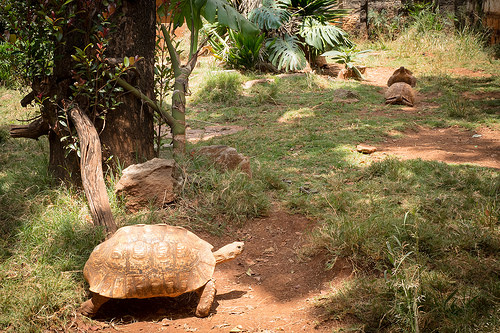<image>
Is the tortoise on the grass? No. The tortoise is not positioned on the grass. They may be near each other, but the tortoise is not supported by or resting on top of the grass. 